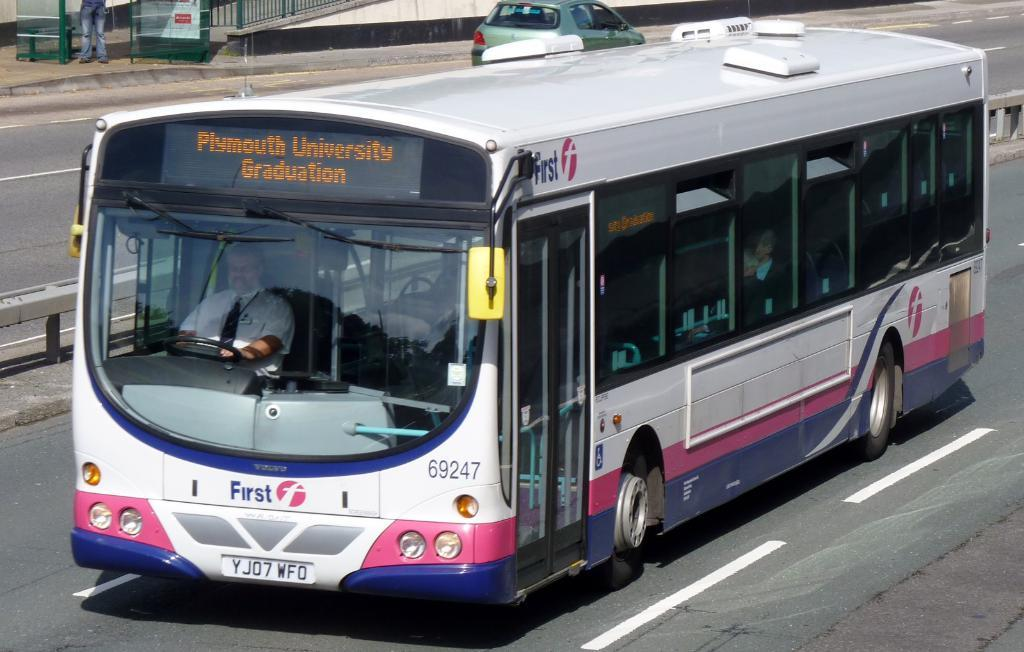What type of vehicle is present in the image? There is a bus in the image. Are there any other vehicles in the image? Yes, there is a car in the image. Where are the bus and car located? Both the bus and car are on the road. Who is driving the bus? There is a person driving the bus. What can be seen on the left side of the image? There is an iron fence on the left side of the image. Are there any people near the iron fence? Yes, a person's legs are visible near the iron fence. How many oranges are being smashed by the bus in the image? There are no oranges present in the image, and the bus is not smashing anything. 